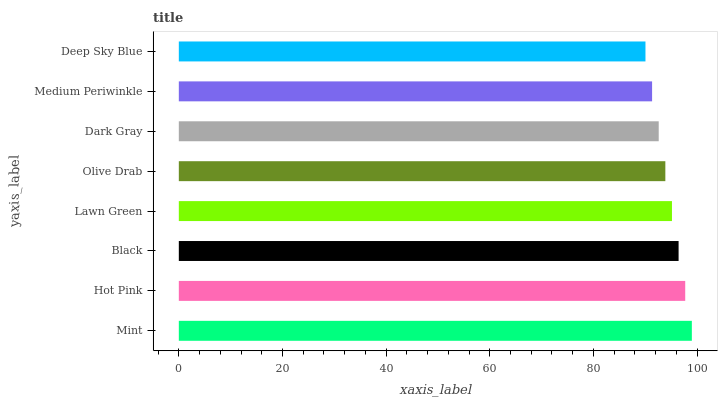Is Deep Sky Blue the minimum?
Answer yes or no. Yes. Is Mint the maximum?
Answer yes or no. Yes. Is Hot Pink the minimum?
Answer yes or no. No. Is Hot Pink the maximum?
Answer yes or no. No. Is Mint greater than Hot Pink?
Answer yes or no. Yes. Is Hot Pink less than Mint?
Answer yes or no. Yes. Is Hot Pink greater than Mint?
Answer yes or no. No. Is Mint less than Hot Pink?
Answer yes or no. No. Is Lawn Green the high median?
Answer yes or no. Yes. Is Olive Drab the low median?
Answer yes or no. Yes. Is Dark Gray the high median?
Answer yes or no. No. Is Black the low median?
Answer yes or no. No. 